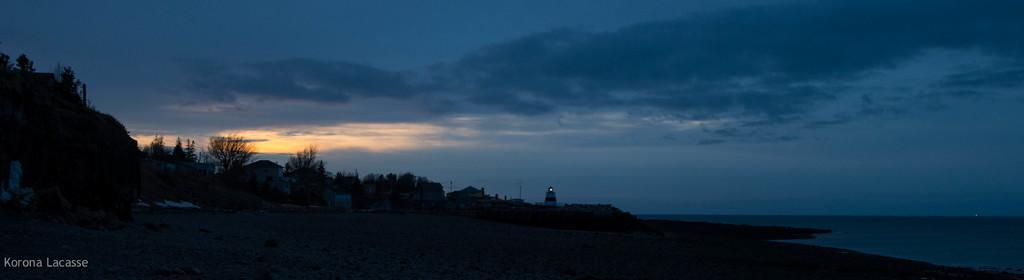What type of terrain is visible in the image? There is sand, trees, and grass visible in the image. What type of structures can be seen in the image? There are houses in the image. What natural elements are present in the image? There is water and sky visible in the image. Can you see a pen being used by a snail in the image? There is no pen or snail present in the image. 